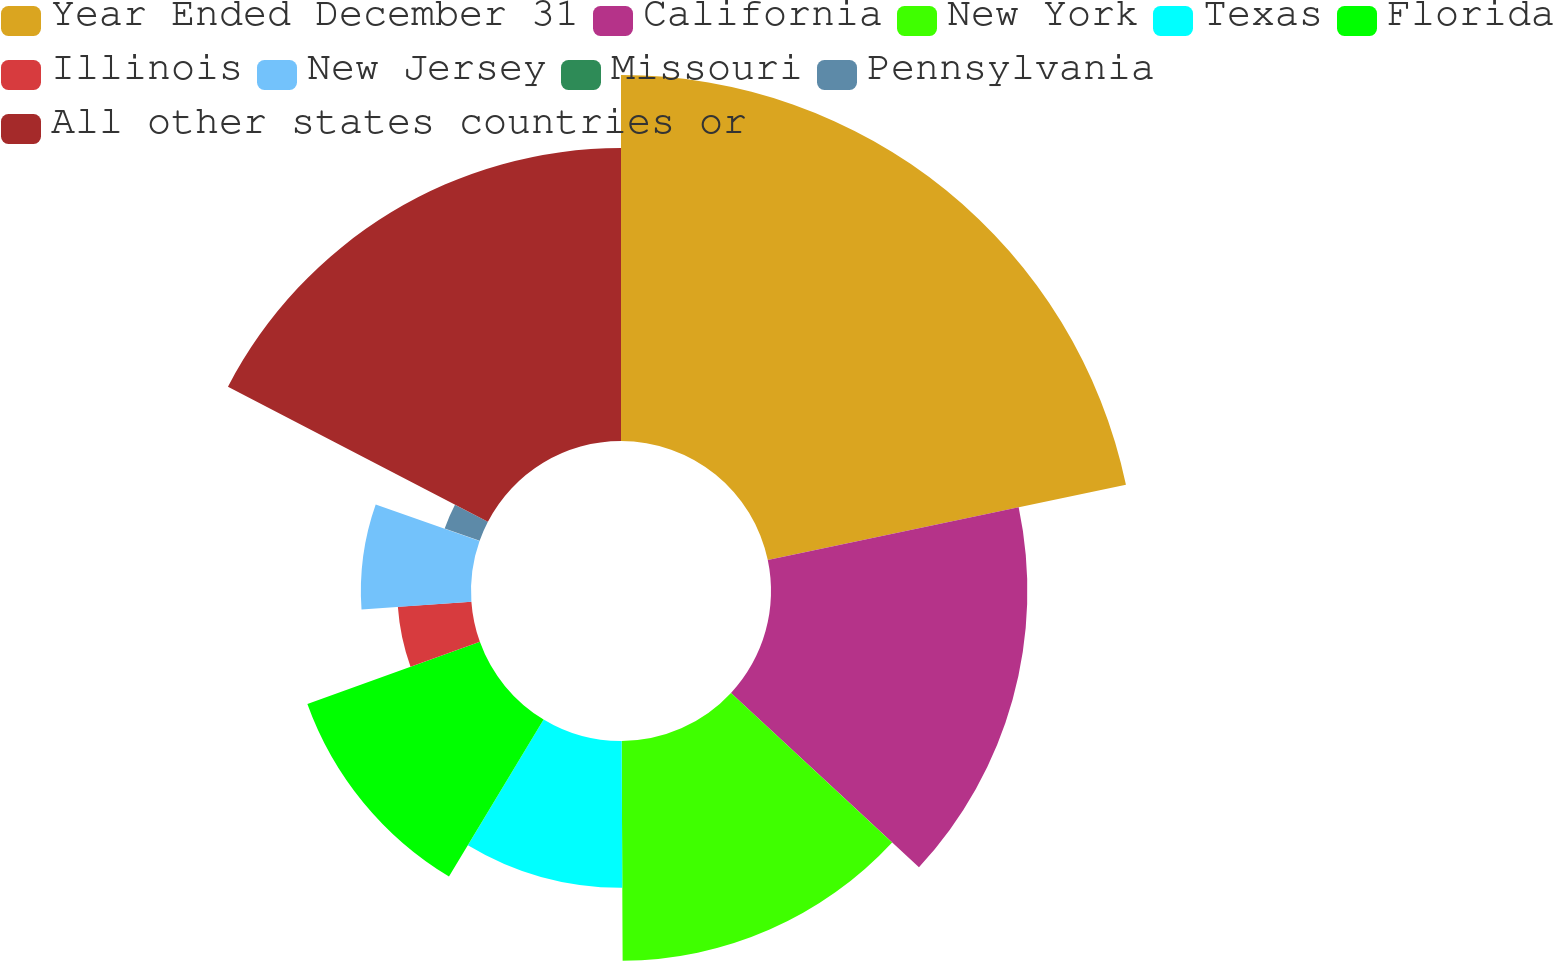Convert chart. <chart><loc_0><loc_0><loc_500><loc_500><pie_chart><fcel>Year Ended December 31<fcel>California<fcel>New York<fcel>Texas<fcel>Florida<fcel>Illinois<fcel>New Jersey<fcel>Missouri<fcel>Pennsylvania<fcel>All other states countries or<nl><fcel>21.7%<fcel>15.2%<fcel>13.03%<fcel>8.7%<fcel>10.87%<fcel>4.37%<fcel>6.53%<fcel>0.03%<fcel>2.2%<fcel>17.37%<nl></chart> 